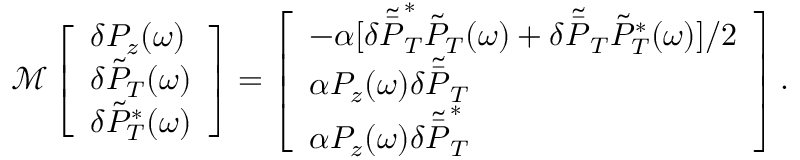Convert formula to latex. <formula><loc_0><loc_0><loc_500><loc_500>\begin{array} { r } { \mathcal { M } \left [ \begin{array} { l } { \delta P _ { z } ( \omega ) } \\ { \delta \tilde { P } _ { T } ( \omega ) } \\ { \delta \tilde { P } _ { T } ^ { * } ( \omega ) } \end{array} \right ] = \left [ \begin{array} { l } { - \alpha [ \delta \tilde { \bar { P } } _ { T } ^ { * } \tilde { P } _ { T } ( \omega ) + \delta \tilde { \bar { P } } _ { T } \tilde { P } _ { T } ^ { * } ( \omega ) ] / 2 } \\ { \alpha P _ { z } ( \omega ) \delta \tilde { \bar { P } } _ { T } } \\ { \alpha P _ { z } ( \omega ) \delta \tilde { \bar { P } } _ { T } ^ { * } } \end{array} \right ] . } \end{array}</formula> 